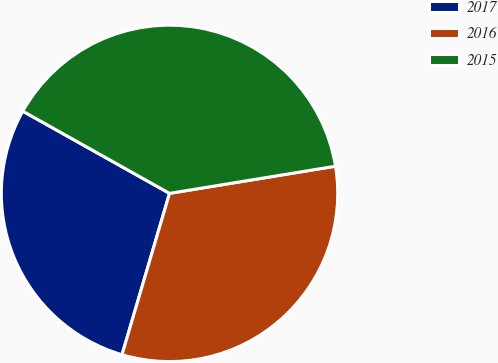<chart> <loc_0><loc_0><loc_500><loc_500><pie_chart><fcel>2017<fcel>2016<fcel>2015<nl><fcel>28.57%<fcel>32.14%<fcel>39.29%<nl></chart> 